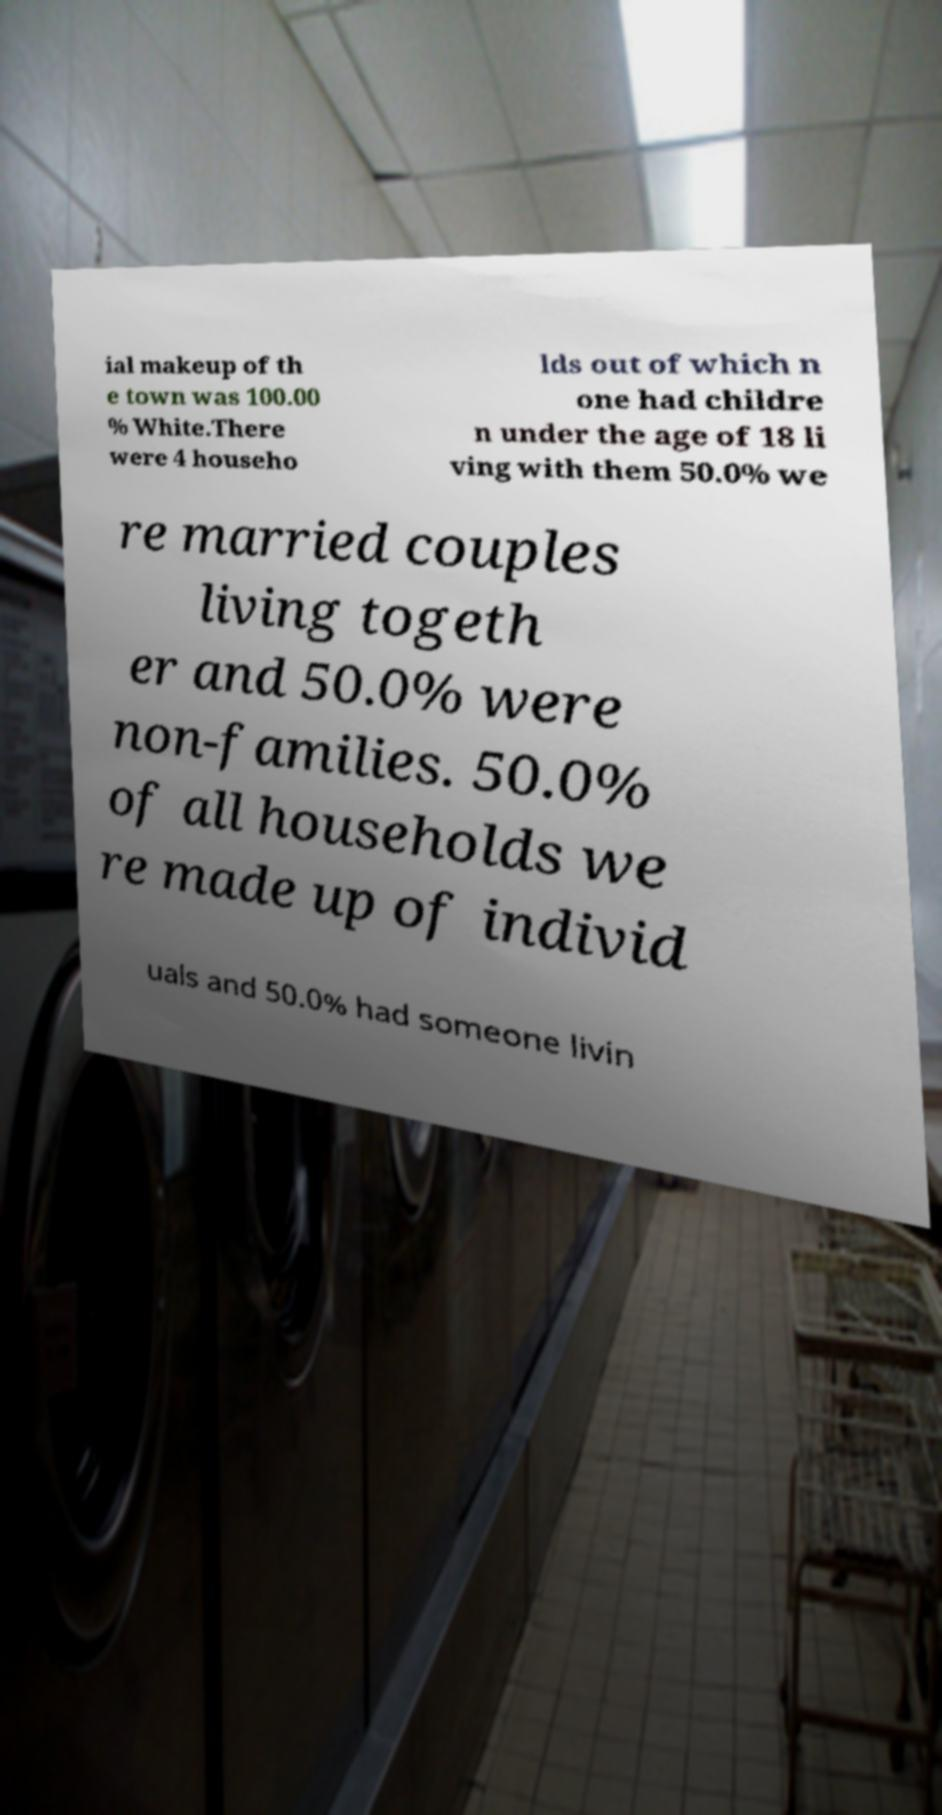Could you extract and type out the text from this image? ial makeup of th e town was 100.00 % White.There were 4 househo lds out of which n one had childre n under the age of 18 li ving with them 50.0% we re married couples living togeth er and 50.0% were non-families. 50.0% of all households we re made up of individ uals and 50.0% had someone livin 